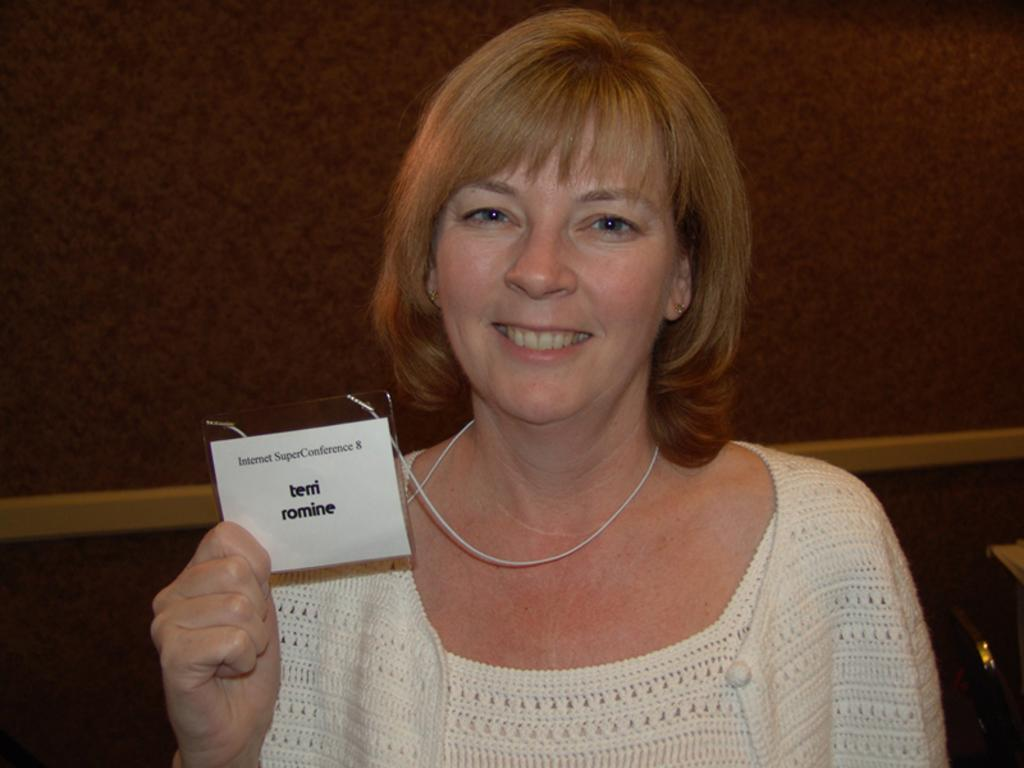What is the main structure in the image? There is a big wall in the image. Who is present in the image? There is a woman in the image. What is the woman holding in the image? The woman is holding an ID card. What can be seen on the surface in the image? There are objects on the surface in the image. What type of carpenter is working on the wall in the image? There is no carpenter present in the image, nor is anyone working on the wall. What is the woman learning in the image? The image does not provide any information about the woman learning anything. 